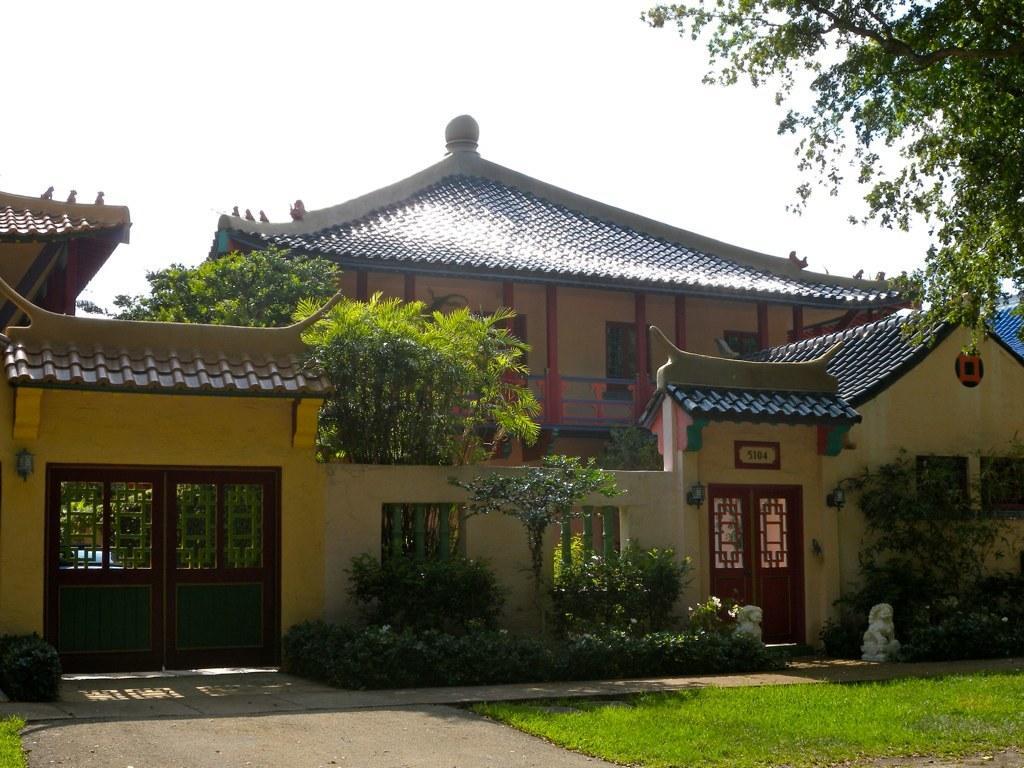Please provide a concise description of this image. In this image there is a building with trees and plants, in front of the building there is a surface of the grass and there is a tree. In the background there is the sky. 